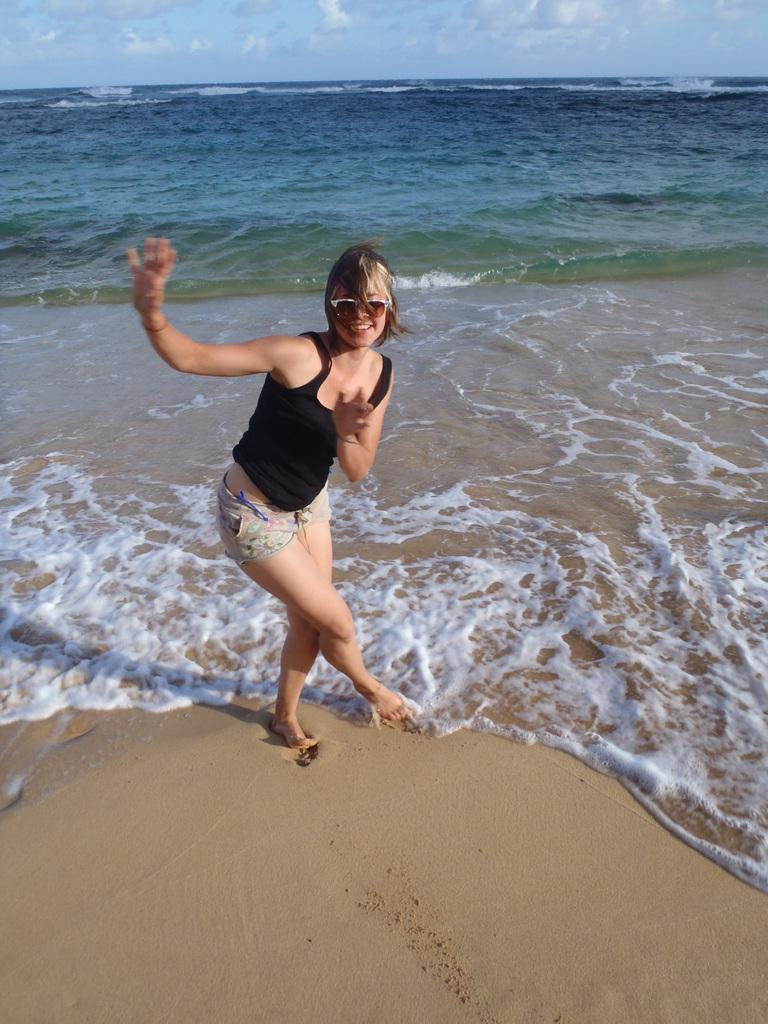Who is the main subject in the image? There is a woman in the image. What is the woman wearing on her upper body? The woman is wearing a black vest. What type of clothing is the woman wearing on her lower body? The woman is wearing shorts. What natural element can be seen in the image? There is water visible in the image. What type of map can be seen in the woman's hand in the image? There is no map present in the image; the woman is not holding anything in her hand. 